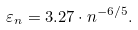Convert formula to latex. <formula><loc_0><loc_0><loc_500><loc_500>\varepsilon _ { n } = 3 . 2 7 \cdot n ^ { - 6 / 5 } .</formula> 